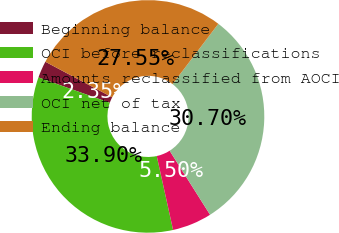<chart> <loc_0><loc_0><loc_500><loc_500><pie_chart><fcel>Beginning balance<fcel>OCI before reclassifications<fcel>Amounts reclassified from AOCI<fcel>OCI net of tax<fcel>Ending balance<nl><fcel>2.35%<fcel>33.9%<fcel>5.5%<fcel>30.7%<fcel>27.55%<nl></chart> 